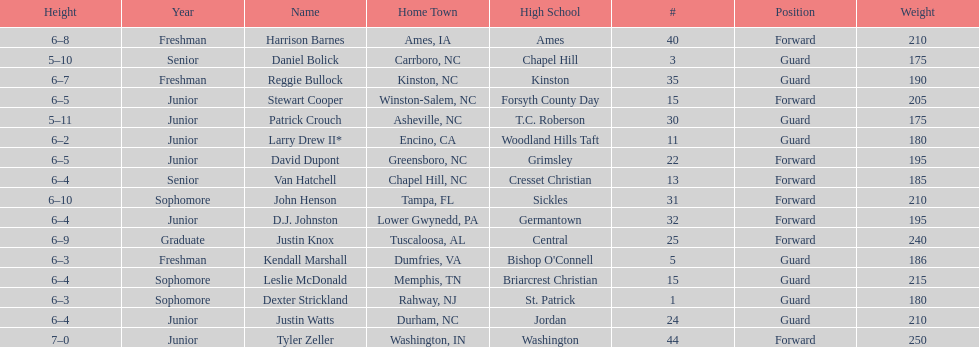Tallest player on the team Tyler Zeller. 